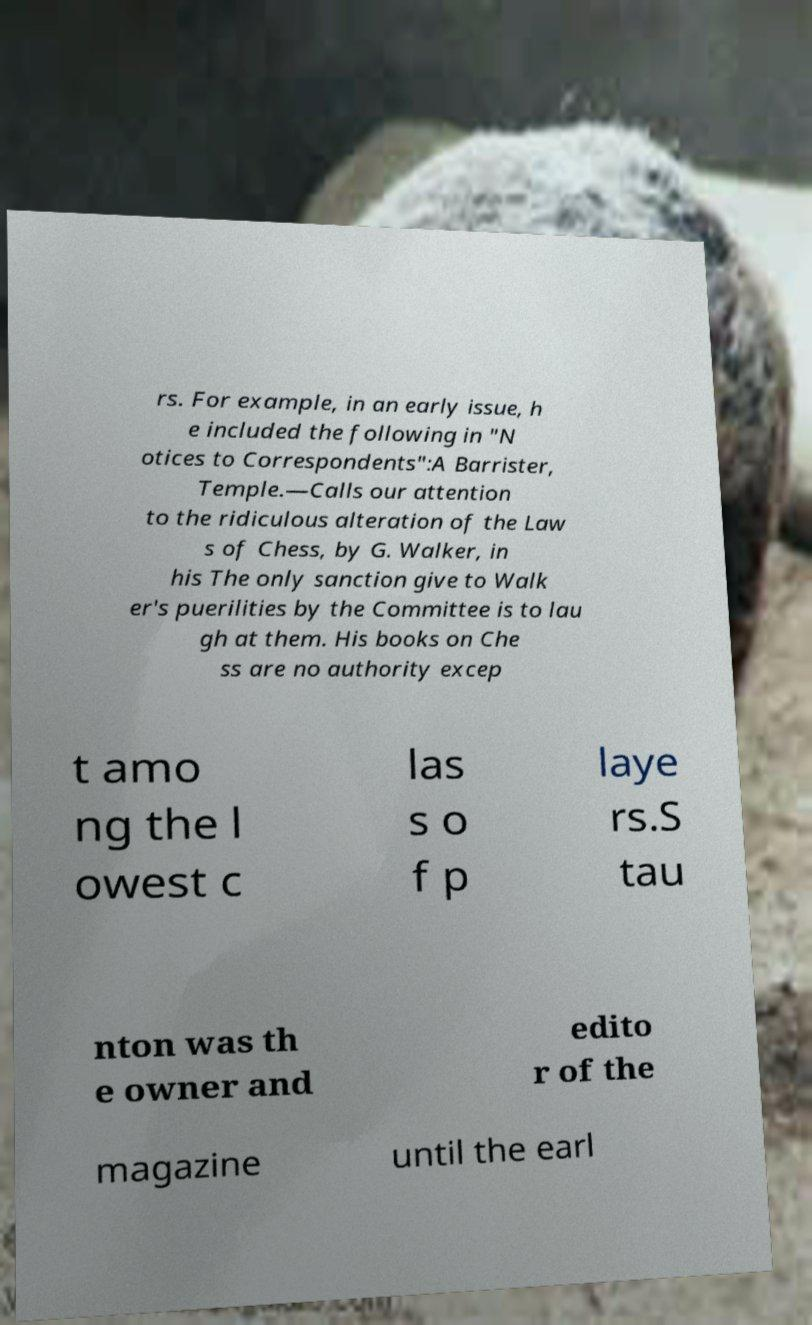Can you accurately transcribe the text from the provided image for me? rs. For example, in an early issue, h e included the following in "N otices to Correspondents":A Barrister, Temple.—Calls our attention to the ridiculous alteration of the Law s of Chess, by G. Walker, in his The only sanction give to Walk er's puerilities by the Committee is to lau gh at them. His books on Che ss are no authority excep t amo ng the l owest c las s o f p laye rs.S tau nton was th e owner and edito r of the magazine until the earl 